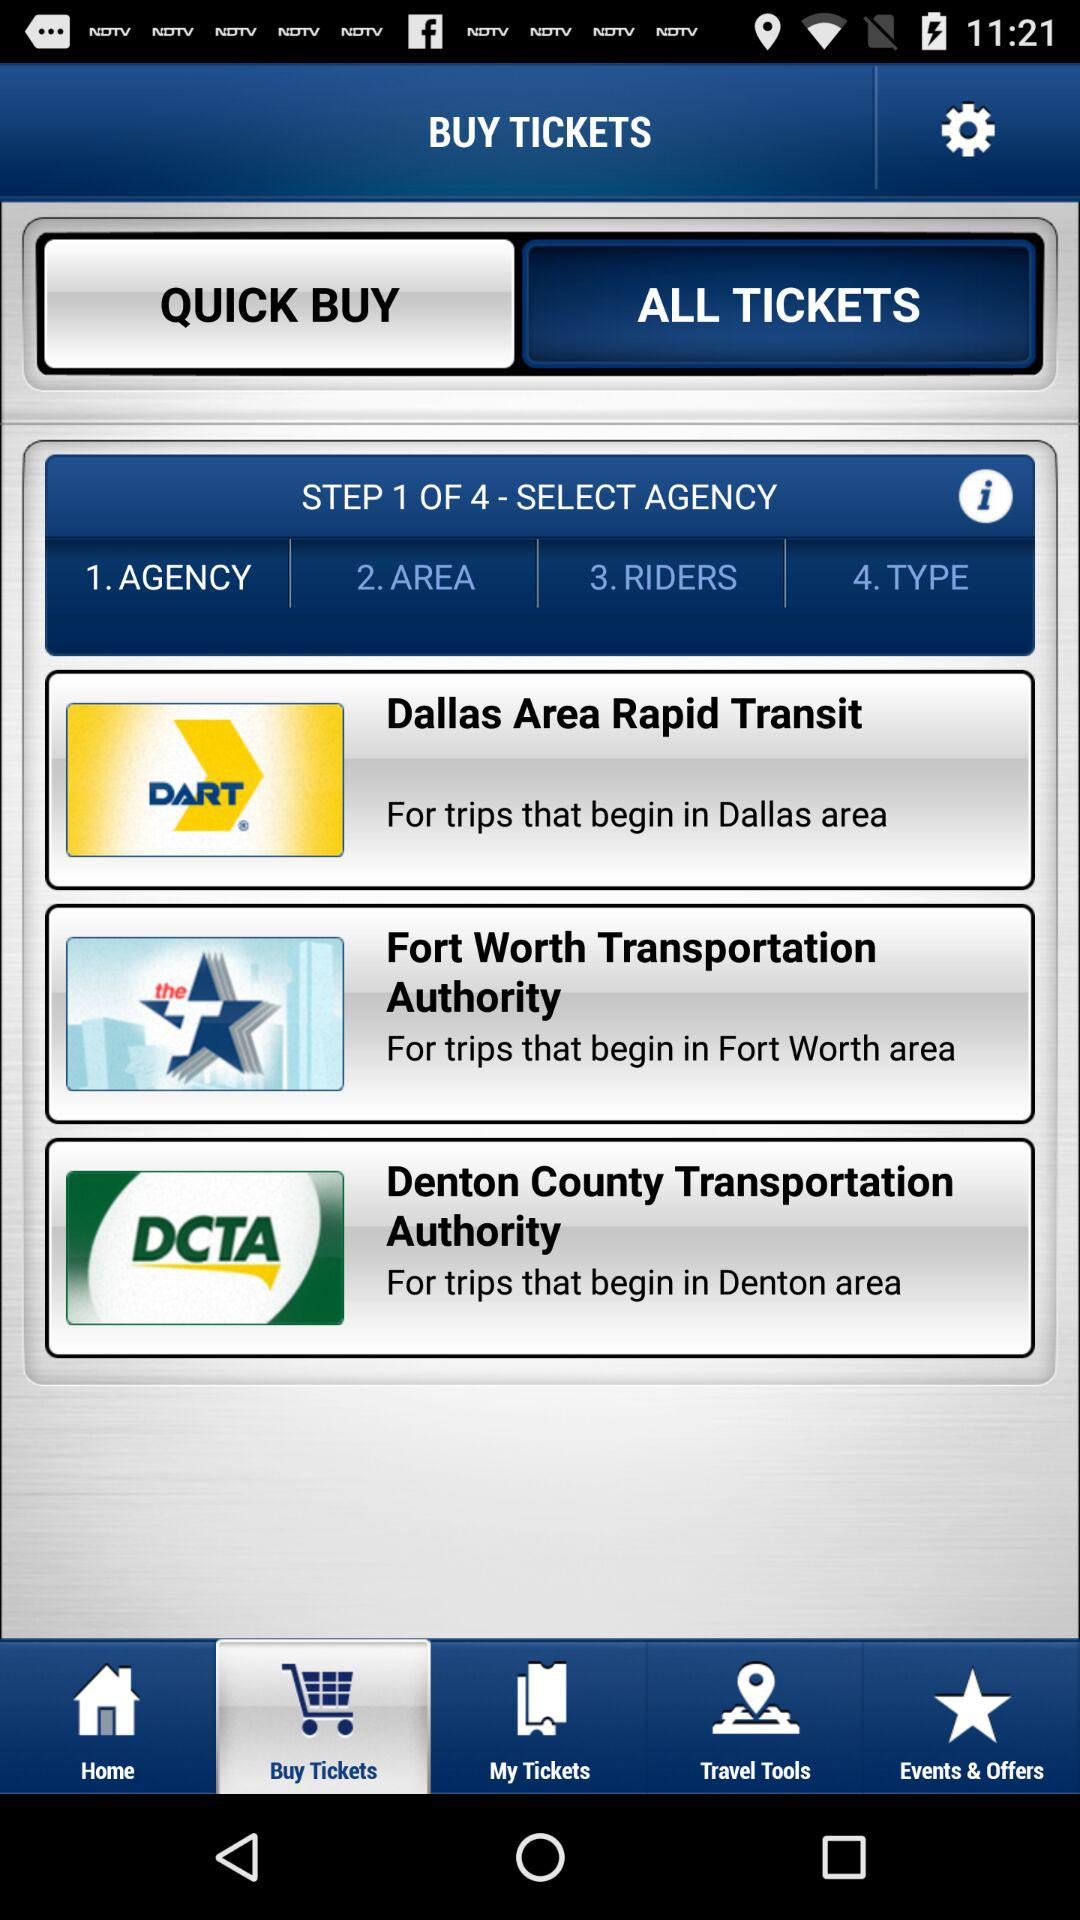Which agency should I choose for a trip starting in the Dallas area? For trips beginning in the Dallas area, you should select Dallas Area Rapid Transit (DART) to ensure you receive the appropriate ticketing options and travel information. 